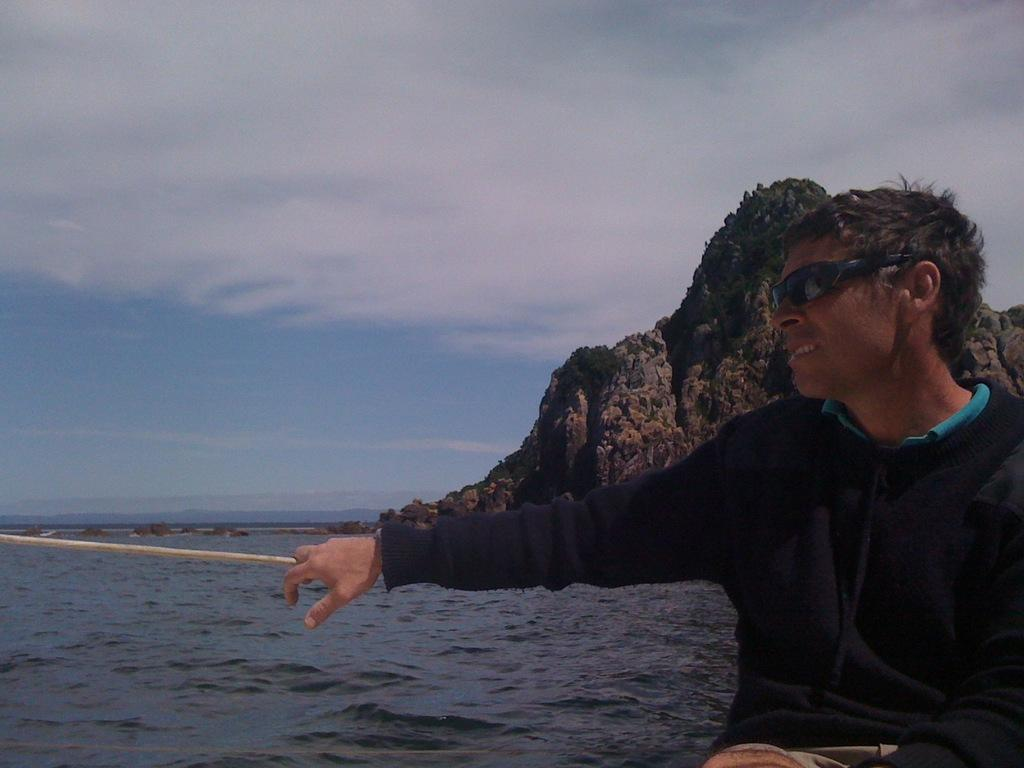Who is present in the image? There is a man in the image. What is the man wearing? The man is wearing clothes and goggles. What is the setting of the image? The image depicts a mountain. What else can be seen in the image besides the man and the mountain? There is water and the sky visible in the image, as well as a rope. What type of grain is being stored in the can in the image? There is no can or grain present in the image. Who is the friend that the man is talking to in the image? There is no friend present in the image; the man is alone. 